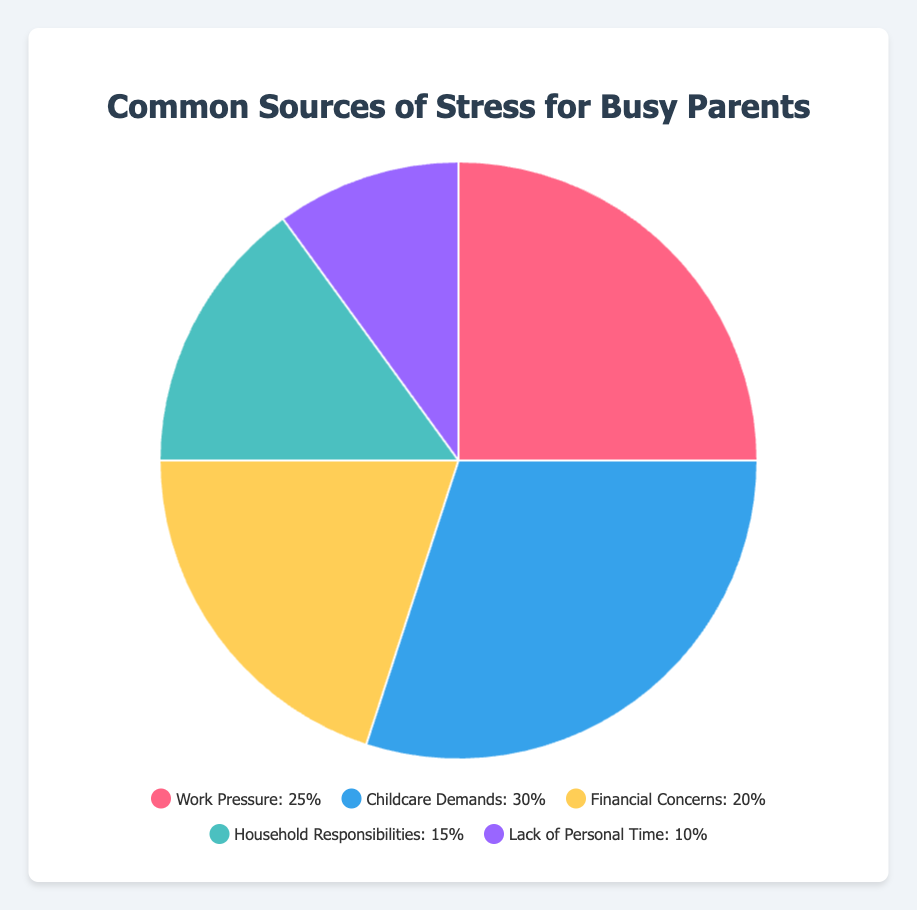How many more percentage points is "Childcare Demands" than "Lack of Personal Time"? "Childcare Demands" is 30% and "Lack of Personal Time" is 10%. The difference is 30% - 10% = 20% points.
Answer: 20% points What is the combined percentage of "Work Pressure" and "Financial Concerns"? "Work Pressure" is 25% and "Financial Concerns" is 20%. The combined percentage is 25% + 20% = 45%.
Answer: 45% Which source of stress has the smallest percentage? By looking at the percentages in the figure, "Lack of Personal Time" has the smallest value at 10%.
Answer: Lack of Personal Time Which two sources of stress have a total percentage of 45%? "Household Responsibilities" is 15% and "Financial Concerns" is 20%. Adding them gives 15% + 20% = 35%. Similarly, "Work Pressure" is 25% and "Lack of Personal Time" is 10%. Adding them gives 25% + 10% = 35%. The pair with 45% are "Work Pressure" and "Financial Concerns" (25% + 20%).
Answer: Work Pressure and Financial Concerns What is the average percentage of all the sources of stress? Add all percentages: 25% (Work Pressure) + 30% (Childcare Demands) + 20% (Financial Concerns) + 15% (Household Responsibilities) + 10% (Lack of Personal Time) = 100%. Divide by 5 sources: 100% / 5 = 20%.
Answer: 20% Which source of stress has the largest percentage? "Childcare Demands" has the largest percentage at 30%.
Answer: Childcare Demands How does the percentage of "Household Responsibilities" compare to "Financial Concerns"? "Household Responsibilities" is 15%, while "Financial Concerns" is 20%. "Household Responsibilities" is 5 percentage points less than "Financial Concerns".
Answer: Less by 5% What color represents the "Work Pressure" category in the chart? "Work Pressure" is represented by a red slice.
Answer: Red 